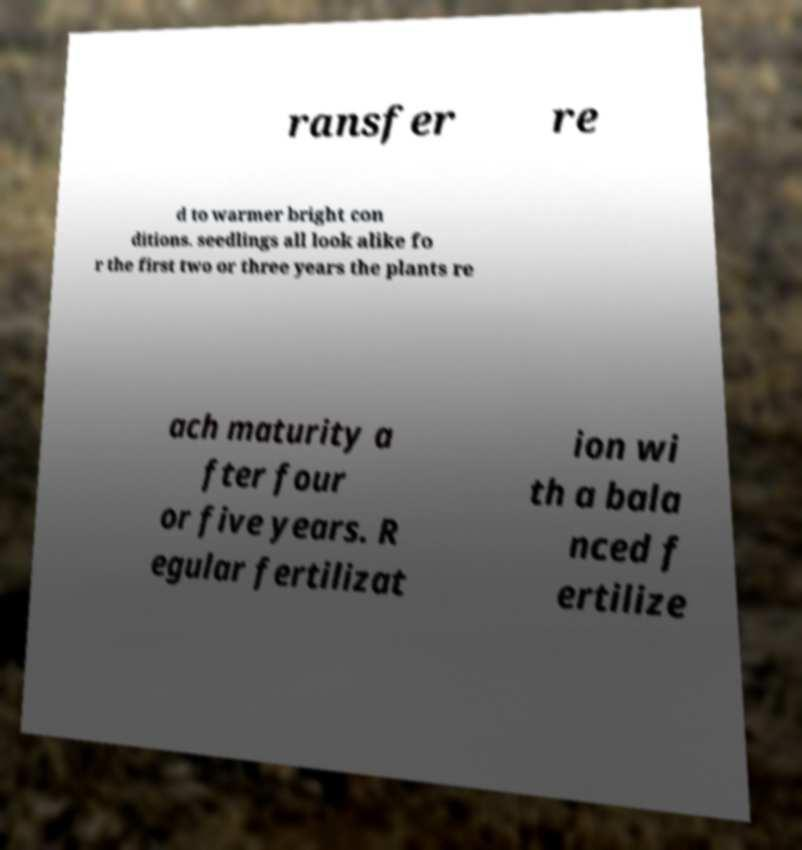Could you extract and type out the text from this image? ransfer re d to warmer bright con ditions. seedlings all look alike fo r the first two or three years the plants re ach maturity a fter four or five years. R egular fertilizat ion wi th a bala nced f ertilize 